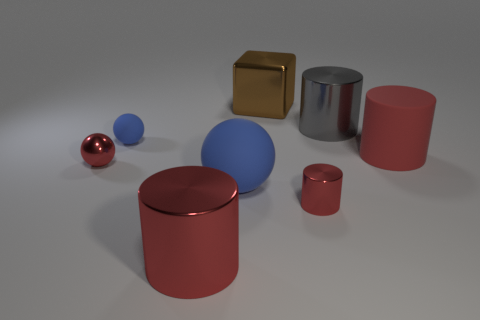Subtract all purple balls. How many red cylinders are left? 3 Subtract 1 cylinders. How many cylinders are left? 3 Add 1 big gray matte spheres. How many objects exist? 9 Subtract all blocks. How many objects are left? 7 Subtract all large green shiny things. Subtract all large brown things. How many objects are left? 7 Add 2 red rubber cylinders. How many red rubber cylinders are left? 3 Add 4 large blue balls. How many large blue balls exist? 5 Subtract 0 brown spheres. How many objects are left? 8 